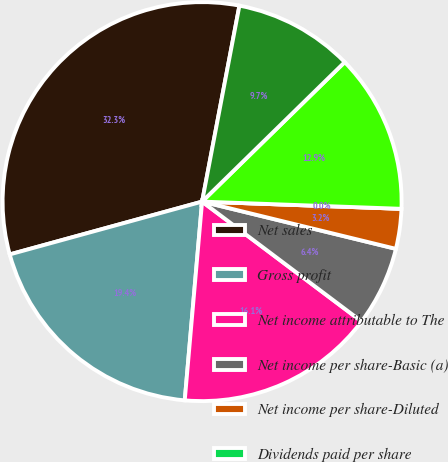<chart> <loc_0><loc_0><loc_500><loc_500><pie_chart><fcel>Net sales<fcel>Gross profit<fcel>Net income attributable to The<fcel>Net income per share-Basic (a)<fcel>Net income per share-Diluted<fcel>Dividends paid per share<fcel>High<fcel>Low<nl><fcel>32.26%<fcel>19.35%<fcel>16.13%<fcel>6.45%<fcel>3.23%<fcel>0.0%<fcel>12.9%<fcel>9.68%<nl></chart> 